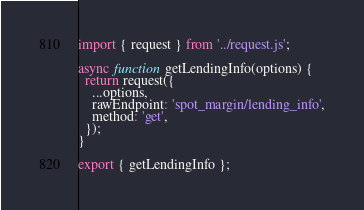Convert code to text. <code><loc_0><loc_0><loc_500><loc_500><_JavaScript_>import { request } from '../request.js';

async function getLendingInfo(options) {
  return request({
    ...options,
    rawEndpoint: 'spot_margin/lending_info',
    method: 'get',
  });
}

export { getLendingInfo };
</code> 